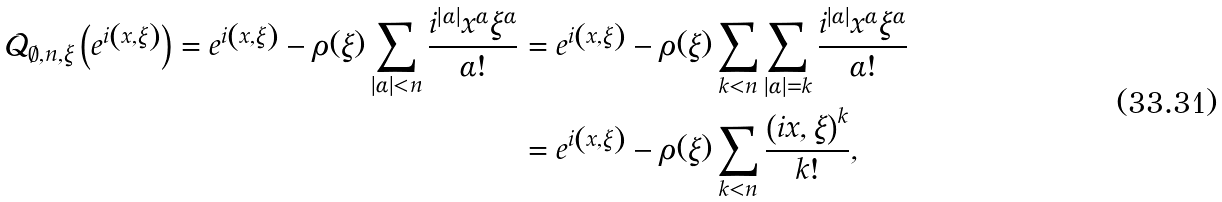<formula> <loc_0><loc_0><loc_500><loc_500>\mathcal { Q } _ { \emptyset , n , \xi } \left ( e ^ { i \left ( x , \xi \right ) } \right ) = e ^ { i \left ( x , \xi \right ) } - \rho ( \xi ) \sum _ { \left | \alpha \right | < n } \frac { i ^ { \left | \alpha \right | } x ^ { \alpha } \xi ^ { \alpha } } { \alpha ! } & = e ^ { i \left ( x , \xi \right ) } - \rho ( \xi ) \sum _ { k < n } \sum _ { \left | \alpha \right | = k } \frac { i ^ { \left | \alpha \right | } x ^ { \alpha } \xi ^ { \alpha } } { \alpha ! } \\ & = e ^ { i \left ( x , \xi \right ) } - \rho ( \xi ) \sum _ { k < n } \frac { \left ( i x , \xi \right ) ^ { k } } { k ! } ,</formula> 